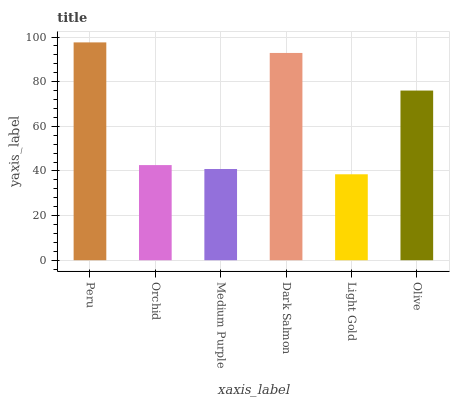Is Light Gold the minimum?
Answer yes or no. Yes. Is Peru the maximum?
Answer yes or no. Yes. Is Orchid the minimum?
Answer yes or no. No. Is Orchid the maximum?
Answer yes or no. No. Is Peru greater than Orchid?
Answer yes or no. Yes. Is Orchid less than Peru?
Answer yes or no. Yes. Is Orchid greater than Peru?
Answer yes or no. No. Is Peru less than Orchid?
Answer yes or no. No. Is Olive the high median?
Answer yes or no. Yes. Is Orchid the low median?
Answer yes or no. Yes. Is Orchid the high median?
Answer yes or no. No. Is Light Gold the low median?
Answer yes or no. No. 